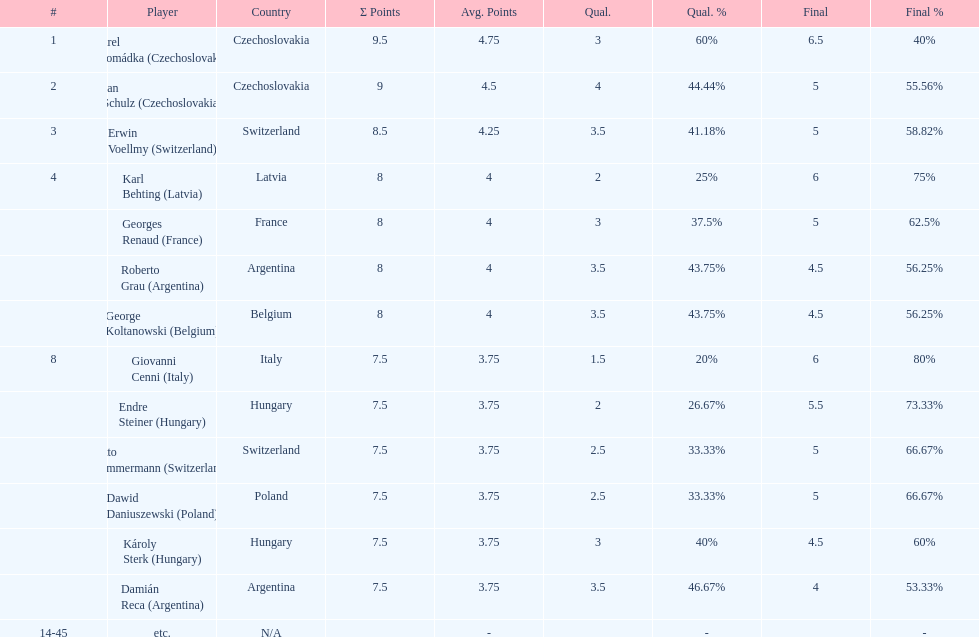How many players tied for 4th place? 4. 